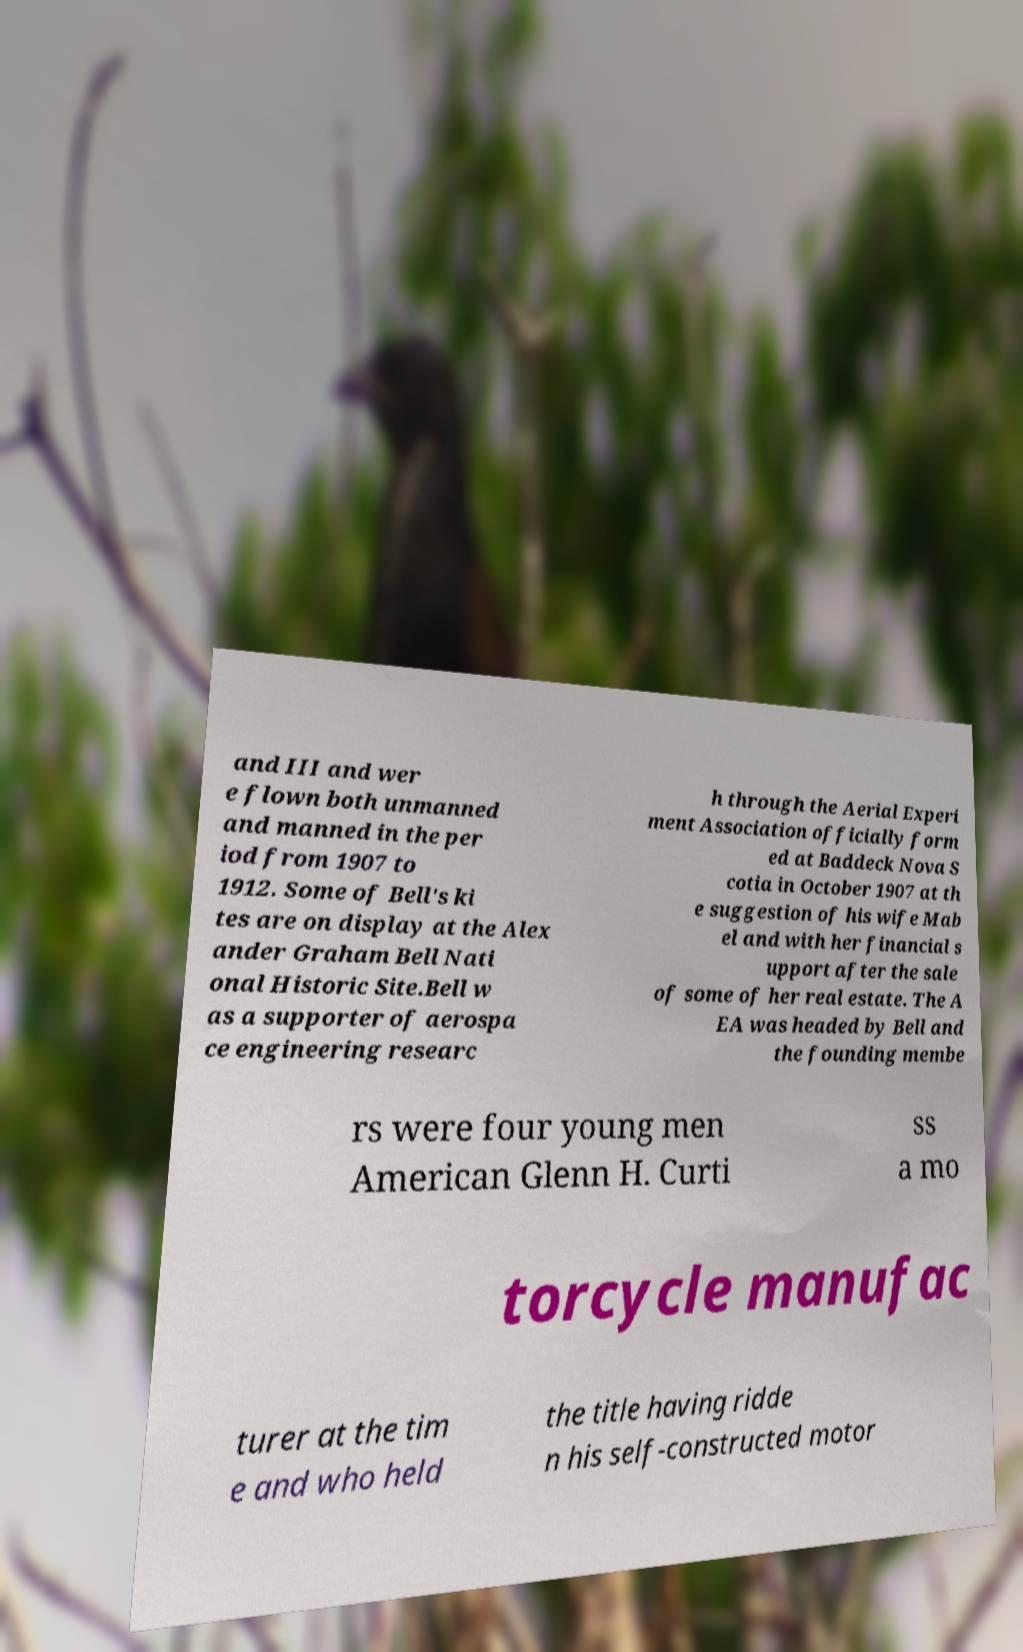For documentation purposes, I need the text within this image transcribed. Could you provide that? and III and wer e flown both unmanned and manned in the per iod from 1907 to 1912. Some of Bell's ki tes are on display at the Alex ander Graham Bell Nati onal Historic Site.Bell w as a supporter of aerospa ce engineering researc h through the Aerial Experi ment Association officially form ed at Baddeck Nova S cotia in October 1907 at th e suggestion of his wife Mab el and with her financial s upport after the sale of some of her real estate. The A EA was headed by Bell and the founding membe rs were four young men American Glenn H. Curti ss a mo torcycle manufac turer at the tim e and who held the title having ridde n his self-constructed motor 